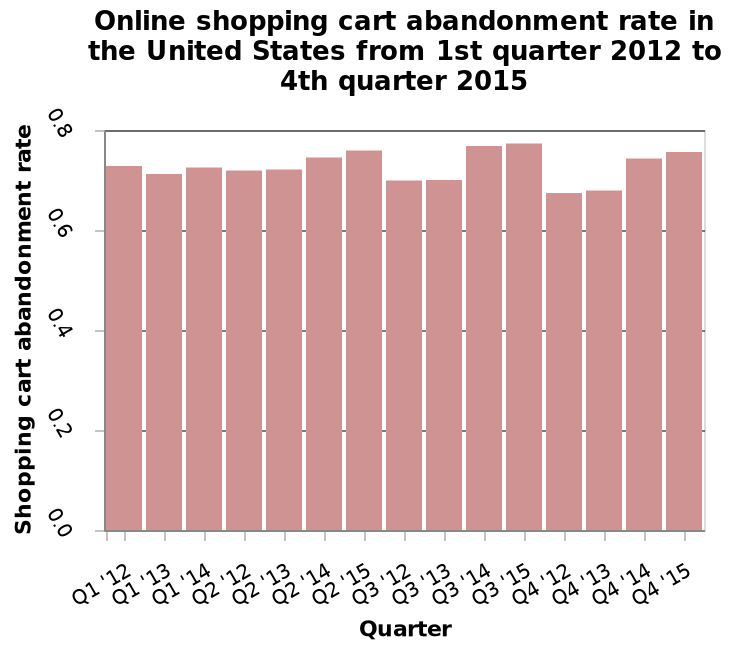<image>
What has been the trend in the shopping cart abandonment rate shown in the chart? The shopping cart abandonment rate has stayed more or less the same throughout the plotting of the chart. please describe the details of the chart Online shopping cart abandonment rate in the United States from 1st quarter 2012 to 4th quarter 2015 is a bar chart. Quarter is measured on the x-axis. On the y-axis, Shopping cart abandonment rate is drawn. In which year period does the chart display the data? The chart displays the data for the period between the 1st quarter of 2012 and the 4th quarter of 2015. Which specific quarters show a higher shopping cart abandonment rate? Quarters 14 and 15 seem to show a higher rate. Has there been a significant fluctuation in the shopping cart abandonment rate? No, the shopping cart abandonment rate has remained relatively stable. Is the online shopping cart abandonment rate in the United States from 1st quarter 2012 to 4th quarter 2015 represented by a pie chart and is the quarter measured on the y-axis while the shopping cart abandonment rate is drawn on the x-axis? No.Online shopping cart abandonment rate in the United States from 1st quarter 2012 to 4th quarter 2015 is a bar chart. Quarter is measured on the x-axis. On the y-axis, Shopping cart abandonment rate is drawn. Has the shopping cart abandonment rate significantly fluctuated throughout the plotting of the chart? No.The shopping cart abandonment rate has stayed more or less the same throughout the plotting of the chart. 